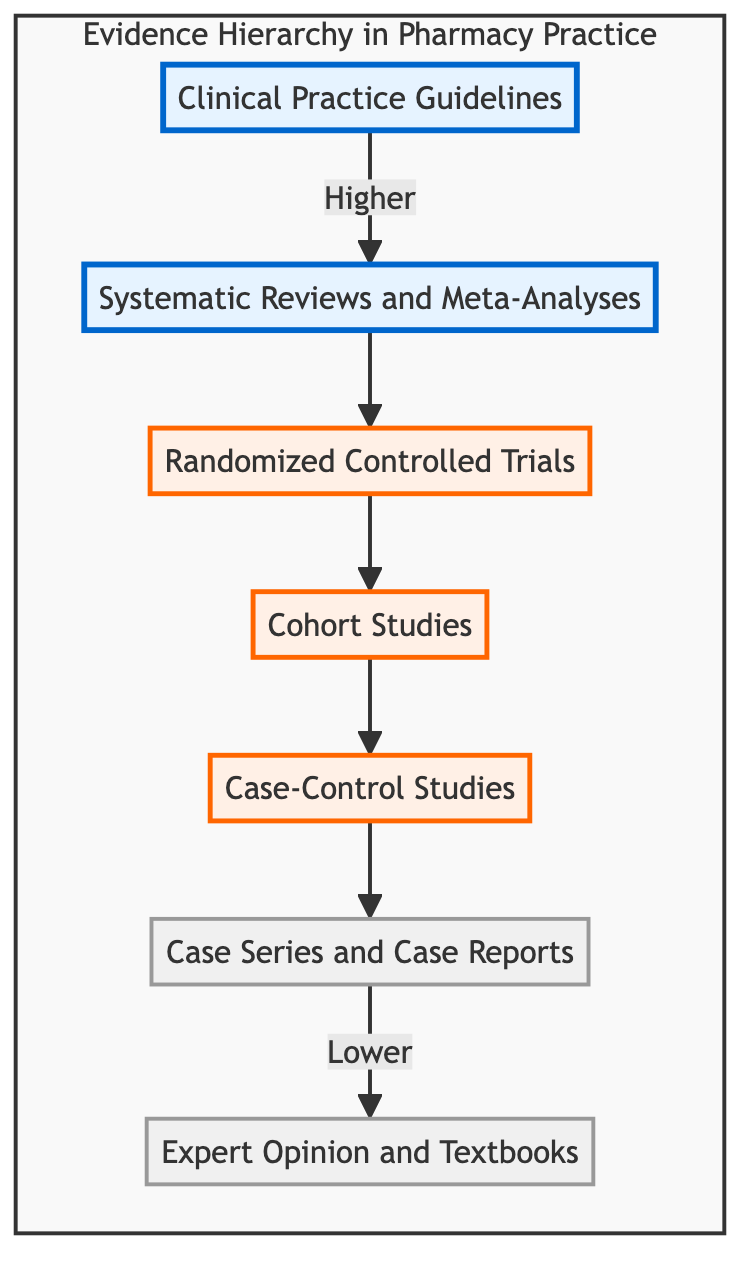What is the top node in the hierarchy? In the diagram, the top node representing the highest level of evidence is "Clinical Practice Guidelines." This can be determined by looking at the starting point of the arrows, which lead to other evidence levels.
Answer: Clinical Practice Guidelines How many levels are there in the hierarchy? The hierarchy consists of six distinct levels, starting from Clinical Practice Guidelines down to Expert Opinion and Textbooks. Each node represents a level in the evidence hierarchy.
Answer: Six Which type of study follows Systematic Reviews and Meta-Analyses? Directly below the Systematic Reviews and Meta-Analyses node in the diagram is the Randomized Controlled Trials node. This indicates that RCTs are a subsequent level of evidence.
Answer: Randomized Controlled Trials What is the relationship between Case-Control Studies and Cohort Studies? Case-Control Studies are positioned directly below Cohort Studies, indicating that they are a lower level of evidence in the hierarchy. Therefore, the relationship is that Case-Control Studies are a subsequent evidence type after Cohort Studies.
Answer: Lower What is the lowest level of evidence shown in the diagram? The lowest level indicated in the evidence hierarchy is "Expert Opinion and Textbooks." This is the final node at the bottom of the diagram.
Answer: Expert Opinion and Textbooks How does Cohort Studies relate to Case Series and Case Reports? Cohort Studies precede Case Series and Case Reports in the evidence hierarchy, indicating that Cohort Studies are a higher level of evidence compared to Case Series and Case Reports.
Answer: Higher In which category do Clinical Practice Guidelines fall? Clinical Practice Guidelines fall into the top level of the evidence hierarchy as indicated by their position at the very top of the diagram.
Answer: Top level What type of evidence is represented immediately before Case Series and Case Reports? Immediately prior to Case Series and Case Reports is Case-Control Studies. This illustrates the sequential order of the levels of evidence in the diagram.
Answer: Case-Control Studies What examples are given for Expert Opinion and Textbooks? An example provided for Expert Opinion and Textbooks is "Goodman & Gilman's: The Pharmacological Basis of Therapeutics." This serves to illustrate the type of resources classified here.
Answer: Goodman & Gilman's: The Pharmacological Basis of Therapeutics 